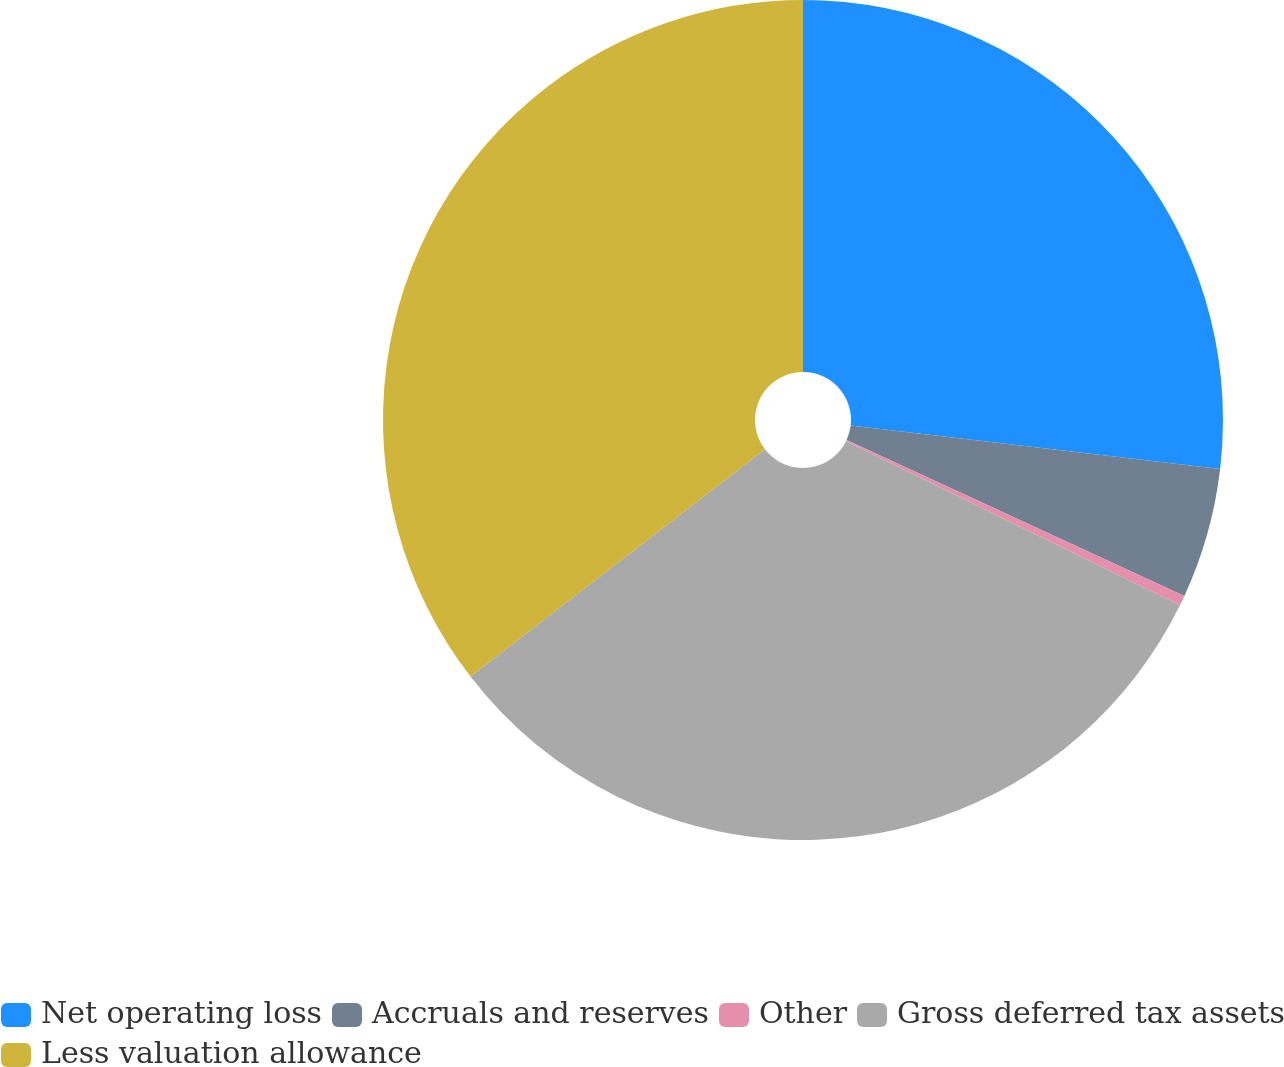Convert chart to OTSL. <chart><loc_0><loc_0><loc_500><loc_500><pie_chart><fcel>Net operating loss<fcel>Accruals and reserves<fcel>Other<fcel>Gross deferred tax assets<fcel>Less valuation allowance<nl><fcel>26.86%<fcel>5.02%<fcel>0.39%<fcel>32.27%<fcel>35.46%<nl></chart> 